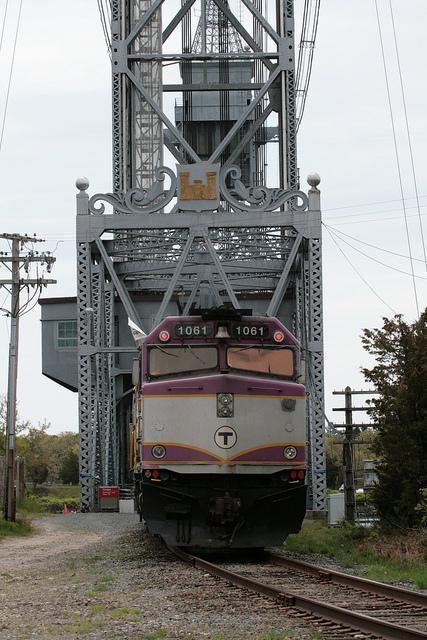How many people are standing?
Give a very brief answer. 0. 